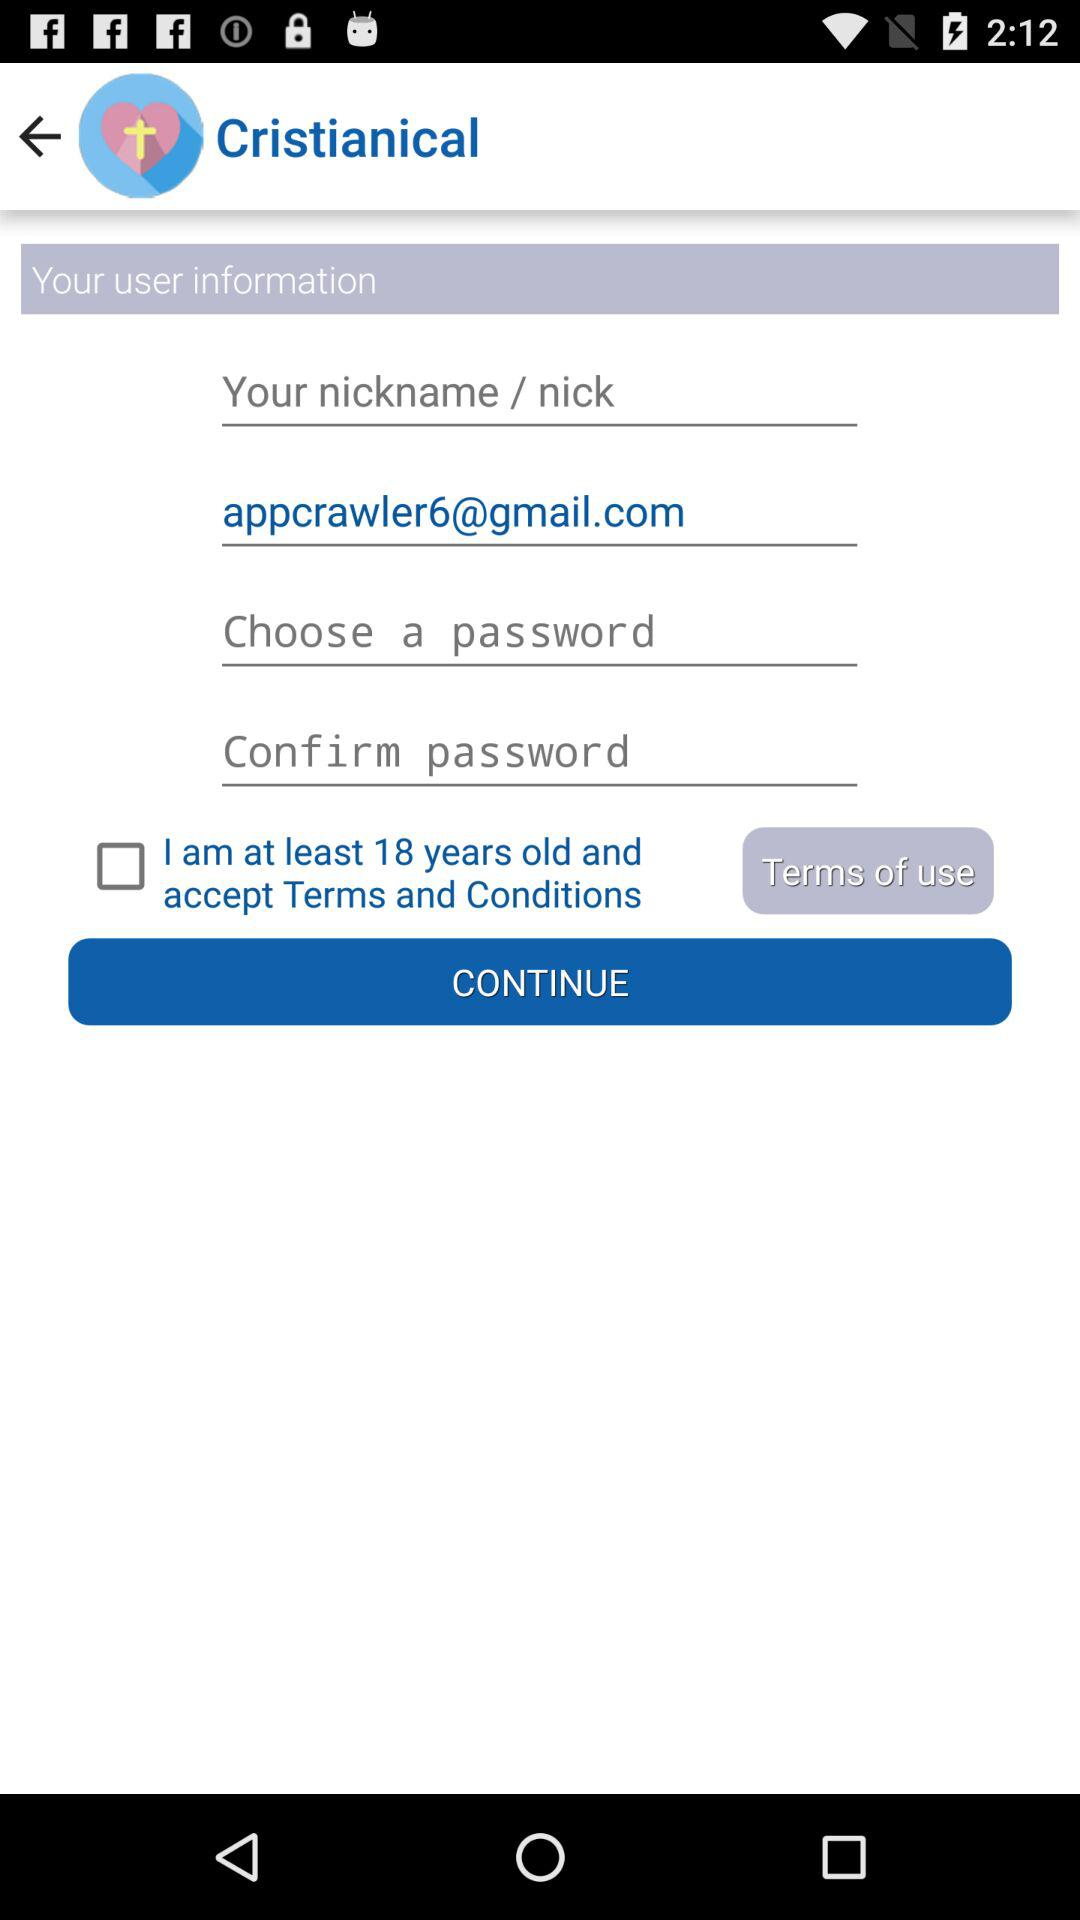What is the email address of the user? The email address is appcrawler6@gmail.com. 